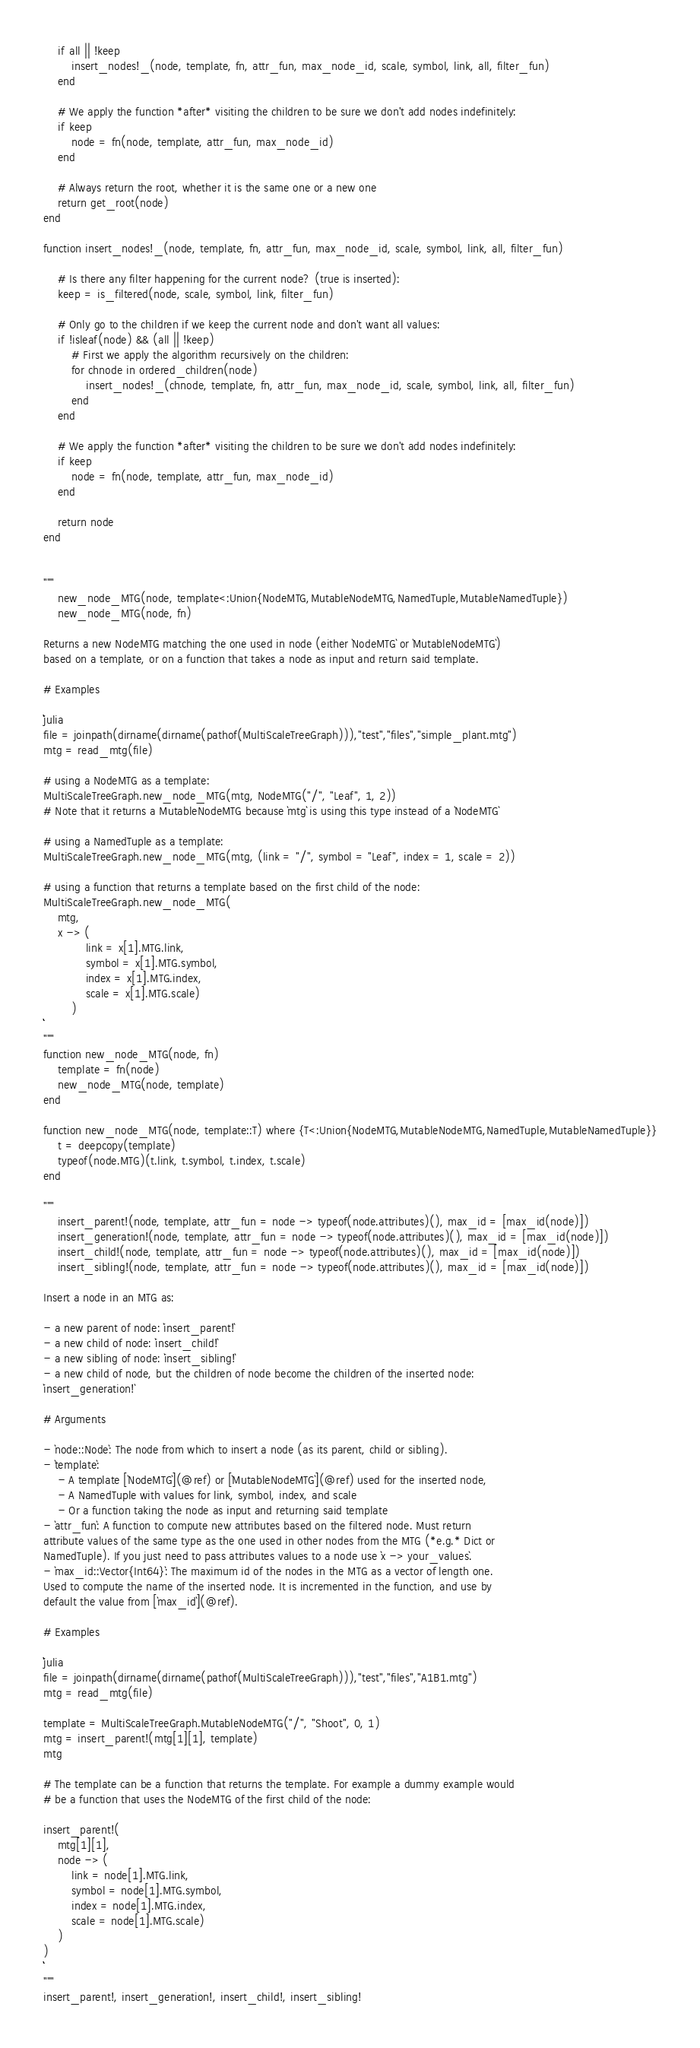Convert code to text. <code><loc_0><loc_0><loc_500><loc_500><_Julia_>    if all || !keep
        insert_nodes!_(node, template, fn, attr_fun, max_node_id, scale, symbol, link, all, filter_fun)
    end

    # We apply the function *after* visiting the children to be sure we don't add nodes indefinitely:
    if keep
        node = fn(node, template, attr_fun, max_node_id)
    end

    # Always return the root, whether it is the same one or a new one
    return get_root(node)
end

function insert_nodes!_(node, template, fn, attr_fun, max_node_id, scale, symbol, link, all, filter_fun)

    # Is there any filter happening for the current node? (true is inserted):
    keep = is_filtered(node, scale, symbol, link, filter_fun)

    # Only go to the children if we keep the current node and don't want all values:
    if !isleaf(node) && (all || !keep)
        # First we apply the algorithm recursively on the children:
        for chnode in ordered_children(node)
            insert_nodes!_(chnode, template, fn, attr_fun, max_node_id, scale, symbol, link, all, filter_fun)
        end
    end

    # We apply the function *after* visiting the children to be sure we don't add nodes indefinitely:
    if keep
        node = fn(node, template, attr_fun, max_node_id)
    end

    return node
end


"""
    new_node_MTG(node, template<:Union{NodeMTG,MutableNodeMTG,NamedTuple,MutableNamedTuple})
    new_node_MTG(node, fn)

Returns a new NodeMTG matching the one used in node (either `NodeMTG` or `MutableNodeMTG`)
based on a template, or on a function that takes a node as input and return said template.

# Examples

```julia
file = joinpath(dirname(dirname(pathof(MultiScaleTreeGraph))),"test","files","simple_plant.mtg")
mtg = read_mtg(file)

# using a NodeMTG as a template:
MultiScaleTreeGraph.new_node_MTG(mtg, NodeMTG("/", "Leaf", 1, 2))
# Note that it returns a MutableNodeMTG because `mtg` is using this type instead of a `NodeMTG`

# using a NamedTuple as a template:
MultiScaleTreeGraph.new_node_MTG(mtg, (link = "/", symbol = "Leaf", index = 1, scale = 2))

# using a function that returns a template based on the first child of the node:
MultiScaleTreeGraph.new_node_MTG(
    mtg,
    x -> (
            link = x[1].MTG.link,
            symbol = x[1].MTG.symbol,
            index = x[1].MTG.index,
            scale = x[1].MTG.scale)
        )
```
"""
function new_node_MTG(node, fn)
    template = fn(node)
    new_node_MTG(node, template)
end

function new_node_MTG(node, template::T) where {T<:Union{NodeMTG,MutableNodeMTG,NamedTuple,MutableNamedTuple}}
    t = deepcopy(template)
    typeof(node.MTG)(t.link, t.symbol, t.index, t.scale)
end

"""
    insert_parent!(node, template, attr_fun = node -> typeof(node.attributes)(), max_id = [max_id(node)])
    insert_generation!(node, template, attr_fun = node -> typeof(node.attributes)(), max_id = [max_id(node)])
    insert_child!(node, template, attr_fun = node -> typeof(node.attributes)(), max_id = [max_id(node)])
    insert_sibling!(node, template, attr_fun = node -> typeof(node.attributes)(), max_id = [max_id(node)])

Insert a node in an MTG as:

- a new parent of node: `insert_parent!`
- a new child of node: `insert_child!`
- a new sibling of node: `insert_sibling!`
- a new child of node, but the children of node become the children of the inserted node:
`insert_generation!`

# Arguments

- `node::Node`: The node from which to insert a node (as its parent, child or sibling).
- `template`:
    - A template [`NodeMTG`](@ref) or [`MutableNodeMTG`](@ref) used for the inserted node,
    - A NamedTuple with values for link, symbol, index, and scale
    - Or a function taking the node as input and returning said template
- `attr_fun`: A function to compute new attributes based on the filtered node. Must return
attribute values of the same type as the one used in other nodes from the MTG (*e.g.* Dict or
NamedTuple). If you just need to pass attributes values to a node use `x -> your_values`.
- `max_id::Vector{Int64}`: The maximum id of the nodes in the MTG as a vector of length one.
Used to compute the name of the inserted node. It is incremented in the function, and use by
default the value from [`max_id`](@ref).

# Examples

```julia
file = joinpath(dirname(dirname(pathof(MultiScaleTreeGraph))),"test","files","A1B1.mtg")
mtg = read_mtg(file)

template = MultiScaleTreeGraph.MutableNodeMTG("/", "Shoot", 0, 1)
mtg = insert_parent!(mtg[1][1], template)
mtg

# The template can be a function that returns the template. For example a dummy example would
# be a function that uses the NodeMTG of the first child of the node:

insert_parent!(
    mtg[1][1],
    node -> (
        link = node[1].MTG.link,
        symbol = node[1].MTG.symbol,
        index = node[1].MTG.index,
        scale = node[1].MTG.scale)
    )
)
```
"""
insert_parent!, insert_generation!, insert_child!, insert_sibling!
</code> 